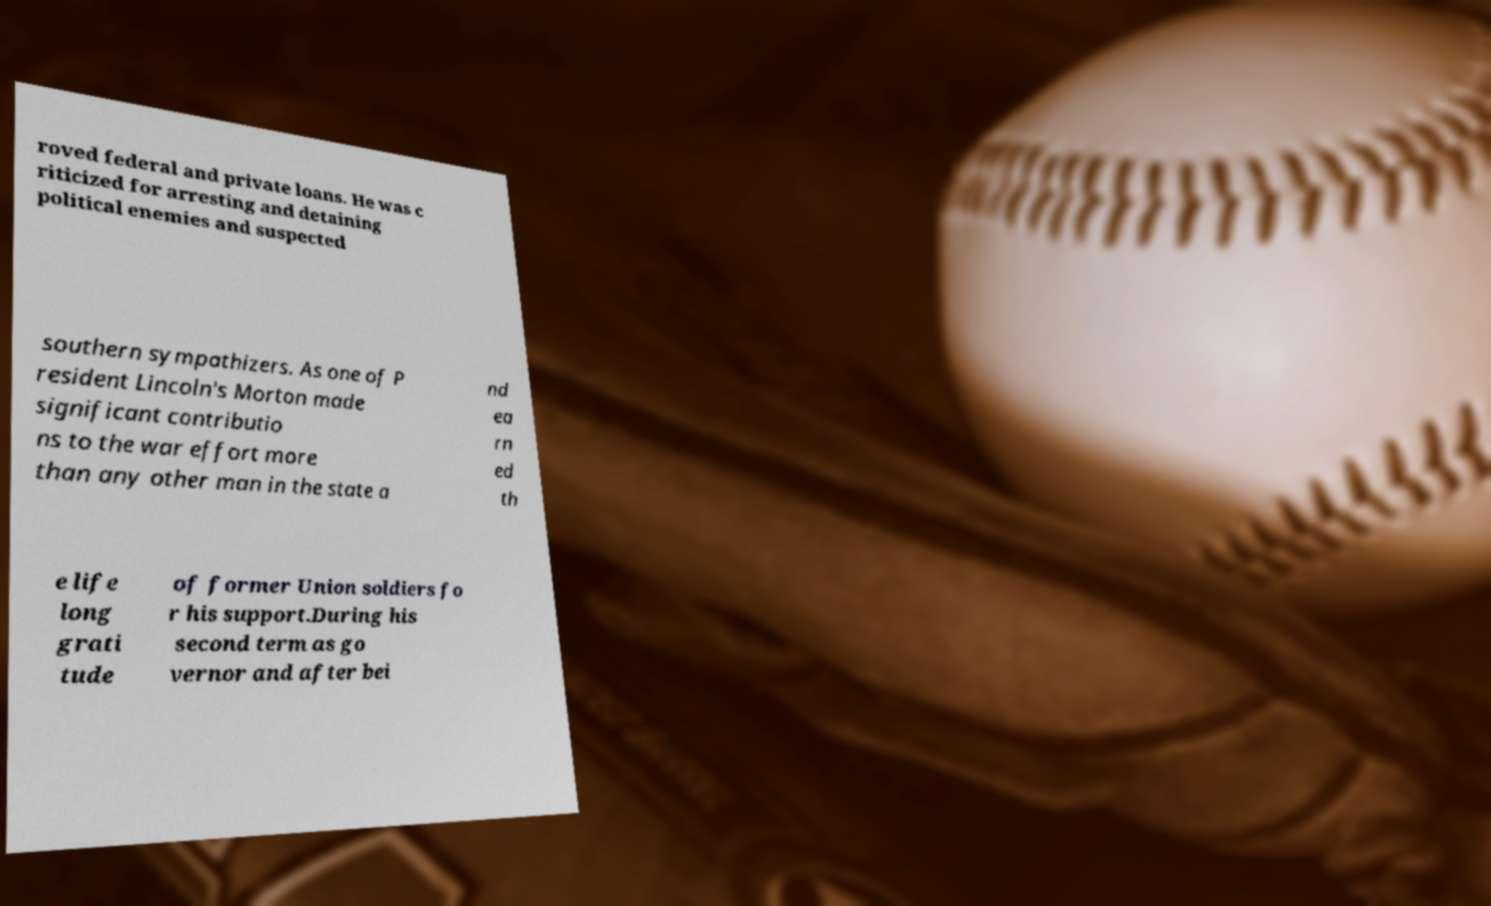Can you accurately transcribe the text from the provided image for me? roved federal and private loans. He was c riticized for arresting and detaining political enemies and suspected southern sympathizers. As one of P resident Lincoln's Morton made significant contributio ns to the war effort more than any other man in the state a nd ea rn ed th e life long grati tude of former Union soldiers fo r his support.During his second term as go vernor and after bei 